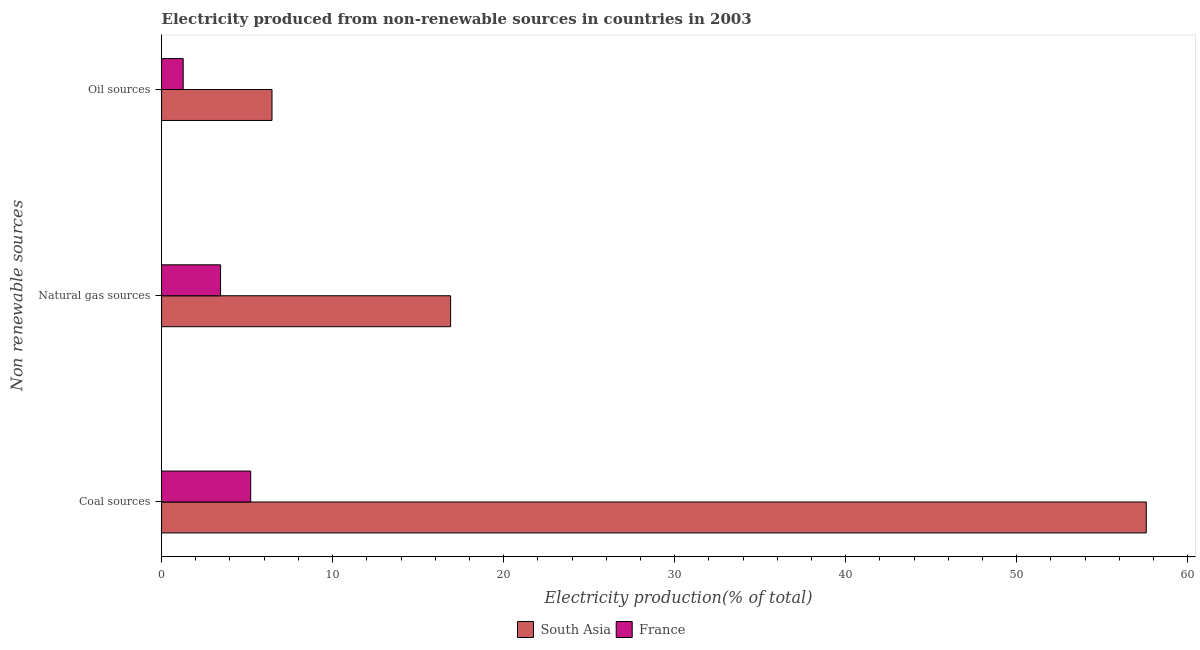How many groups of bars are there?
Your response must be concise. 3. Are the number of bars per tick equal to the number of legend labels?
Your response must be concise. Yes. How many bars are there on the 1st tick from the bottom?
Make the answer very short. 2. What is the label of the 2nd group of bars from the top?
Provide a succinct answer. Natural gas sources. What is the percentage of electricity produced by oil sources in South Asia?
Offer a very short reply. 6.46. Across all countries, what is the maximum percentage of electricity produced by coal?
Keep it short and to the point. 57.57. Across all countries, what is the minimum percentage of electricity produced by oil sources?
Give a very brief answer. 1.26. What is the total percentage of electricity produced by coal in the graph?
Your answer should be very brief. 62.78. What is the difference between the percentage of electricity produced by coal in South Asia and that in France?
Offer a very short reply. 52.36. What is the difference between the percentage of electricity produced by coal in France and the percentage of electricity produced by natural gas in South Asia?
Offer a terse response. -11.69. What is the average percentage of electricity produced by coal per country?
Provide a short and direct response. 31.39. What is the difference between the percentage of electricity produced by natural gas and percentage of electricity produced by coal in South Asia?
Make the answer very short. -40.67. What is the ratio of the percentage of electricity produced by coal in France to that in South Asia?
Provide a short and direct response. 0.09. Is the percentage of electricity produced by natural gas in South Asia less than that in France?
Your answer should be very brief. No. Is the difference between the percentage of electricity produced by coal in France and South Asia greater than the difference between the percentage of electricity produced by natural gas in France and South Asia?
Offer a terse response. No. What is the difference between the highest and the second highest percentage of electricity produced by coal?
Make the answer very short. 52.36. What is the difference between the highest and the lowest percentage of electricity produced by natural gas?
Ensure brevity in your answer.  13.45. How many bars are there?
Ensure brevity in your answer.  6. What is the difference between two consecutive major ticks on the X-axis?
Ensure brevity in your answer.  10. Does the graph contain grids?
Keep it short and to the point. No. Where does the legend appear in the graph?
Provide a short and direct response. Bottom center. How many legend labels are there?
Your response must be concise. 2. How are the legend labels stacked?
Your answer should be compact. Horizontal. What is the title of the graph?
Ensure brevity in your answer.  Electricity produced from non-renewable sources in countries in 2003. Does "Somalia" appear as one of the legend labels in the graph?
Offer a very short reply. No. What is the label or title of the Y-axis?
Your answer should be very brief. Non renewable sources. What is the Electricity production(% of total) in South Asia in Coal sources?
Offer a very short reply. 57.57. What is the Electricity production(% of total) in France in Coal sources?
Ensure brevity in your answer.  5.21. What is the Electricity production(% of total) of South Asia in Natural gas sources?
Provide a succinct answer. 16.9. What is the Electricity production(% of total) in France in Natural gas sources?
Your answer should be compact. 3.45. What is the Electricity production(% of total) of South Asia in Oil sources?
Keep it short and to the point. 6.46. What is the Electricity production(% of total) of France in Oil sources?
Offer a terse response. 1.26. Across all Non renewable sources, what is the maximum Electricity production(% of total) of South Asia?
Give a very brief answer. 57.57. Across all Non renewable sources, what is the maximum Electricity production(% of total) in France?
Make the answer very short. 5.21. Across all Non renewable sources, what is the minimum Electricity production(% of total) in South Asia?
Provide a succinct answer. 6.46. Across all Non renewable sources, what is the minimum Electricity production(% of total) in France?
Your response must be concise. 1.26. What is the total Electricity production(% of total) of South Asia in the graph?
Offer a very short reply. 80.93. What is the total Electricity production(% of total) of France in the graph?
Give a very brief answer. 9.92. What is the difference between the Electricity production(% of total) in South Asia in Coal sources and that in Natural gas sources?
Offer a very short reply. 40.67. What is the difference between the Electricity production(% of total) in France in Coal sources and that in Natural gas sources?
Ensure brevity in your answer.  1.76. What is the difference between the Electricity production(% of total) in South Asia in Coal sources and that in Oil sources?
Offer a terse response. 51.11. What is the difference between the Electricity production(% of total) in France in Coal sources and that in Oil sources?
Your response must be concise. 3.95. What is the difference between the Electricity production(% of total) in South Asia in Natural gas sources and that in Oil sources?
Ensure brevity in your answer.  10.44. What is the difference between the Electricity production(% of total) in France in Natural gas sources and that in Oil sources?
Provide a succinct answer. 2.19. What is the difference between the Electricity production(% of total) in South Asia in Coal sources and the Electricity production(% of total) in France in Natural gas sources?
Give a very brief answer. 54.12. What is the difference between the Electricity production(% of total) of South Asia in Coal sources and the Electricity production(% of total) of France in Oil sources?
Your answer should be very brief. 56.31. What is the difference between the Electricity production(% of total) in South Asia in Natural gas sources and the Electricity production(% of total) in France in Oil sources?
Your answer should be very brief. 15.64. What is the average Electricity production(% of total) in South Asia per Non renewable sources?
Keep it short and to the point. 26.98. What is the average Electricity production(% of total) of France per Non renewable sources?
Provide a succinct answer. 3.31. What is the difference between the Electricity production(% of total) of South Asia and Electricity production(% of total) of France in Coal sources?
Your response must be concise. 52.36. What is the difference between the Electricity production(% of total) in South Asia and Electricity production(% of total) in France in Natural gas sources?
Make the answer very short. 13.45. What is the difference between the Electricity production(% of total) of South Asia and Electricity production(% of total) of France in Oil sources?
Make the answer very short. 5.19. What is the ratio of the Electricity production(% of total) in South Asia in Coal sources to that in Natural gas sources?
Keep it short and to the point. 3.41. What is the ratio of the Electricity production(% of total) in France in Coal sources to that in Natural gas sources?
Your response must be concise. 1.51. What is the ratio of the Electricity production(% of total) in South Asia in Coal sources to that in Oil sources?
Your answer should be compact. 8.92. What is the ratio of the Electricity production(% of total) of France in Coal sources to that in Oil sources?
Offer a terse response. 4.12. What is the ratio of the Electricity production(% of total) of South Asia in Natural gas sources to that in Oil sources?
Offer a terse response. 2.62. What is the ratio of the Electricity production(% of total) of France in Natural gas sources to that in Oil sources?
Ensure brevity in your answer.  2.73. What is the difference between the highest and the second highest Electricity production(% of total) in South Asia?
Provide a succinct answer. 40.67. What is the difference between the highest and the second highest Electricity production(% of total) of France?
Your answer should be very brief. 1.76. What is the difference between the highest and the lowest Electricity production(% of total) of South Asia?
Provide a short and direct response. 51.11. What is the difference between the highest and the lowest Electricity production(% of total) of France?
Your answer should be very brief. 3.95. 